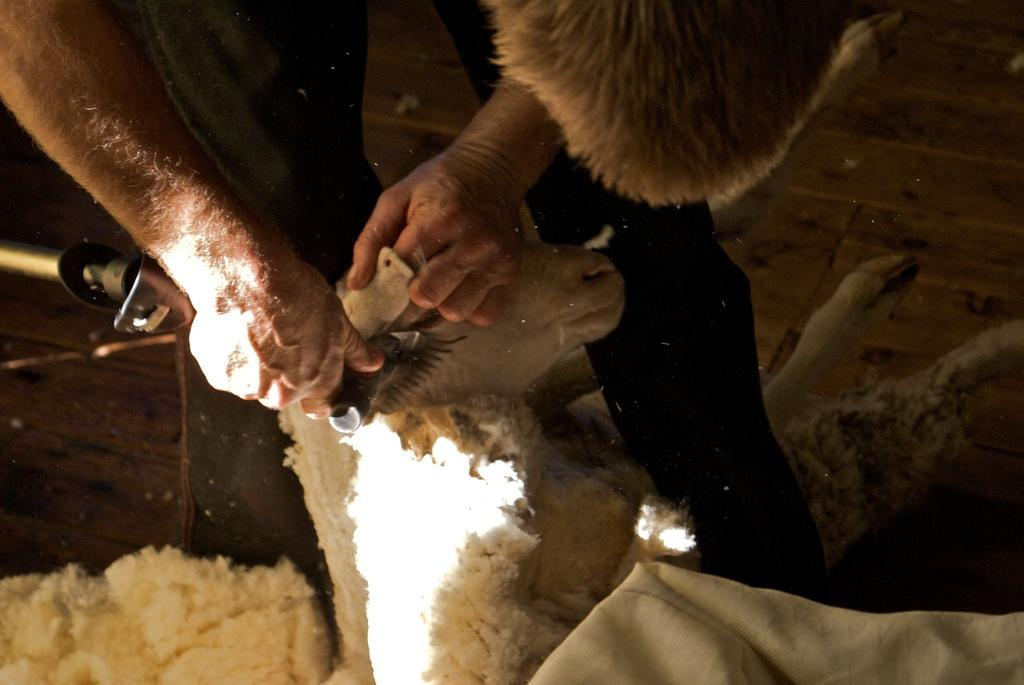What is happening in the image? There is a person in the image who is removing the hair of a sheep. Can you describe the person's activity in more detail? The person is using their hands to remove the hair from the sheep. What type of berry can be seen growing on the twig in the image? There is no berry or twig present in the image; it features a person removing the hair of a sheep. 